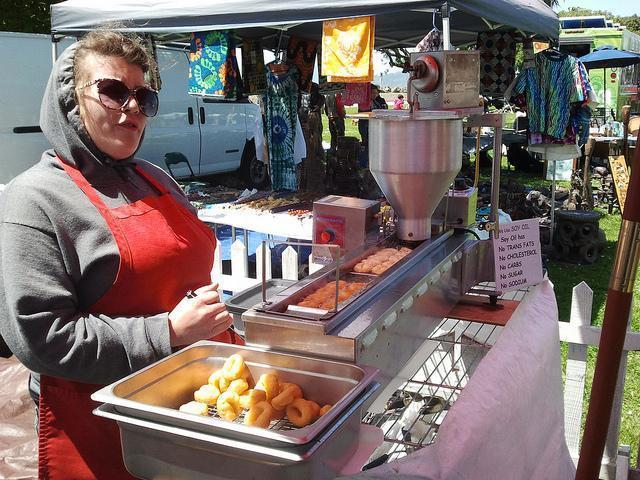How many trucks are in the picture?
Give a very brief answer. 1. How many umbrellas are there?
Give a very brief answer. 2. How many apple iphones are there?
Give a very brief answer. 0. 